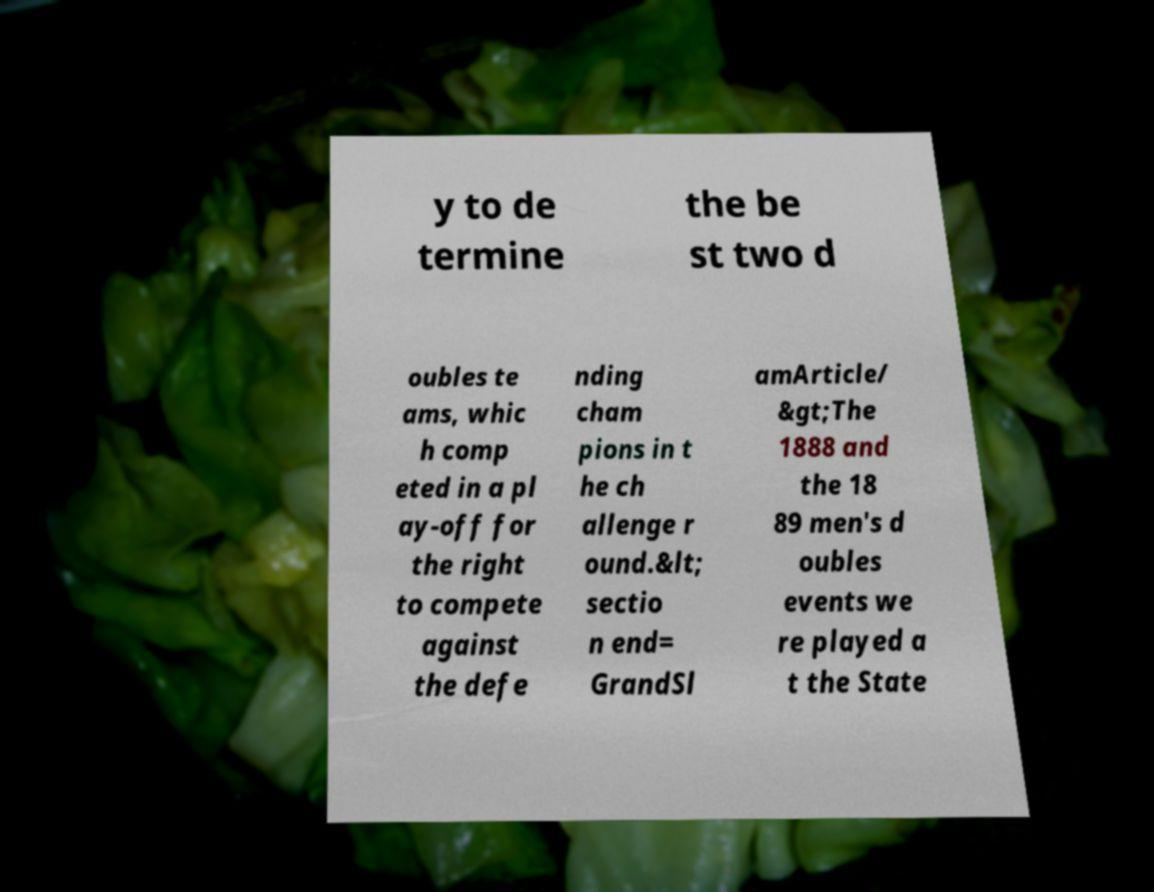Please read and relay the text visible in this image. What does it say? y to de termine the be st two d oubles te ams, whic h comp eted in a pl ay-off for the right to compete against the defe nding cham pions in t he ch allenge r ound.&lt; sectio n end= GrandSl amArticle/ &gt;The 1888 and the 18 89 men's d oubles events we re played a t the State 